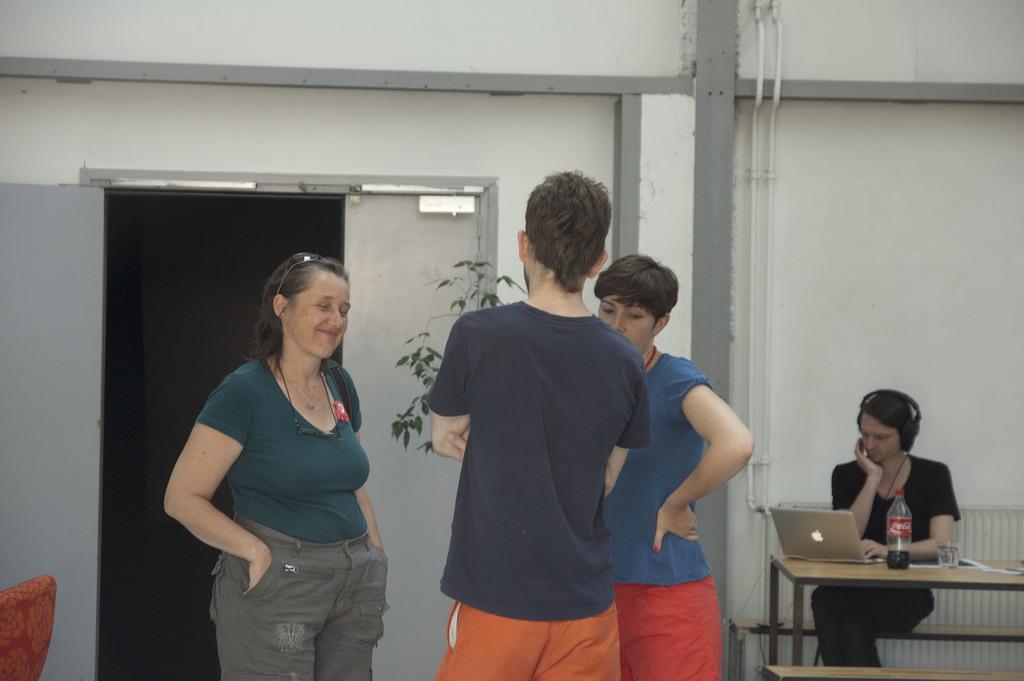How would you summarize this image in a sentence or two? In this picture there are three people standing here, a woman on the left is smiling, on the right there is a person sitting on the chair and there is a table in front of him. There is a laptop, a beverage bottle on the table. In the backdrop there is a door , a chair and a plant. 